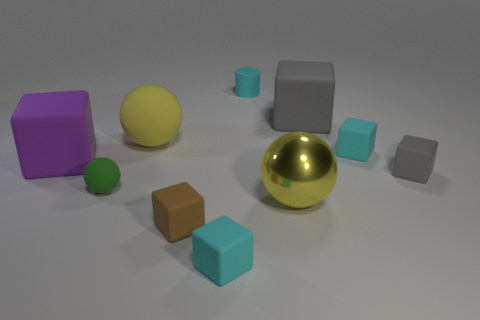What shape is the brown object that is the same size as the green rubber thing?
Offer a terse response. Cube. Is there another tiny brown object that has the same shape as the brown thing?
Give a very brief answer. No. What shape is the gray object to the left of the small cyan matte block that is on the right side of the tiny cylinder?
Offer a terse response. Cube. There is a large purple matte object; what shape is it?
Make the answer very short. Cube. The large yellow thing that is in front of the tiny cyan cube that is behind the yellow ball that is to the right of the brown matte cube is made of what material?
Your response must be concise. Metal. What number of other objects are the same material as the purple object?
Keep it short and to the point. 8. There is a small thing in front of the brown rubber object; what number of cyan cylinders are to the right of it?
Your answer should be compact. 1. How many cylinders are either tiny red things or large yellow matte objects?
Make the answer very short. 0. There is a ball that is on the left side of the brown thing and to the right of the green rubber sphere; what color is it?
Offer a terse response. Yellow. Are there any other things of the same color as the rubber cylinder?
Offer a terse response. Yes. 